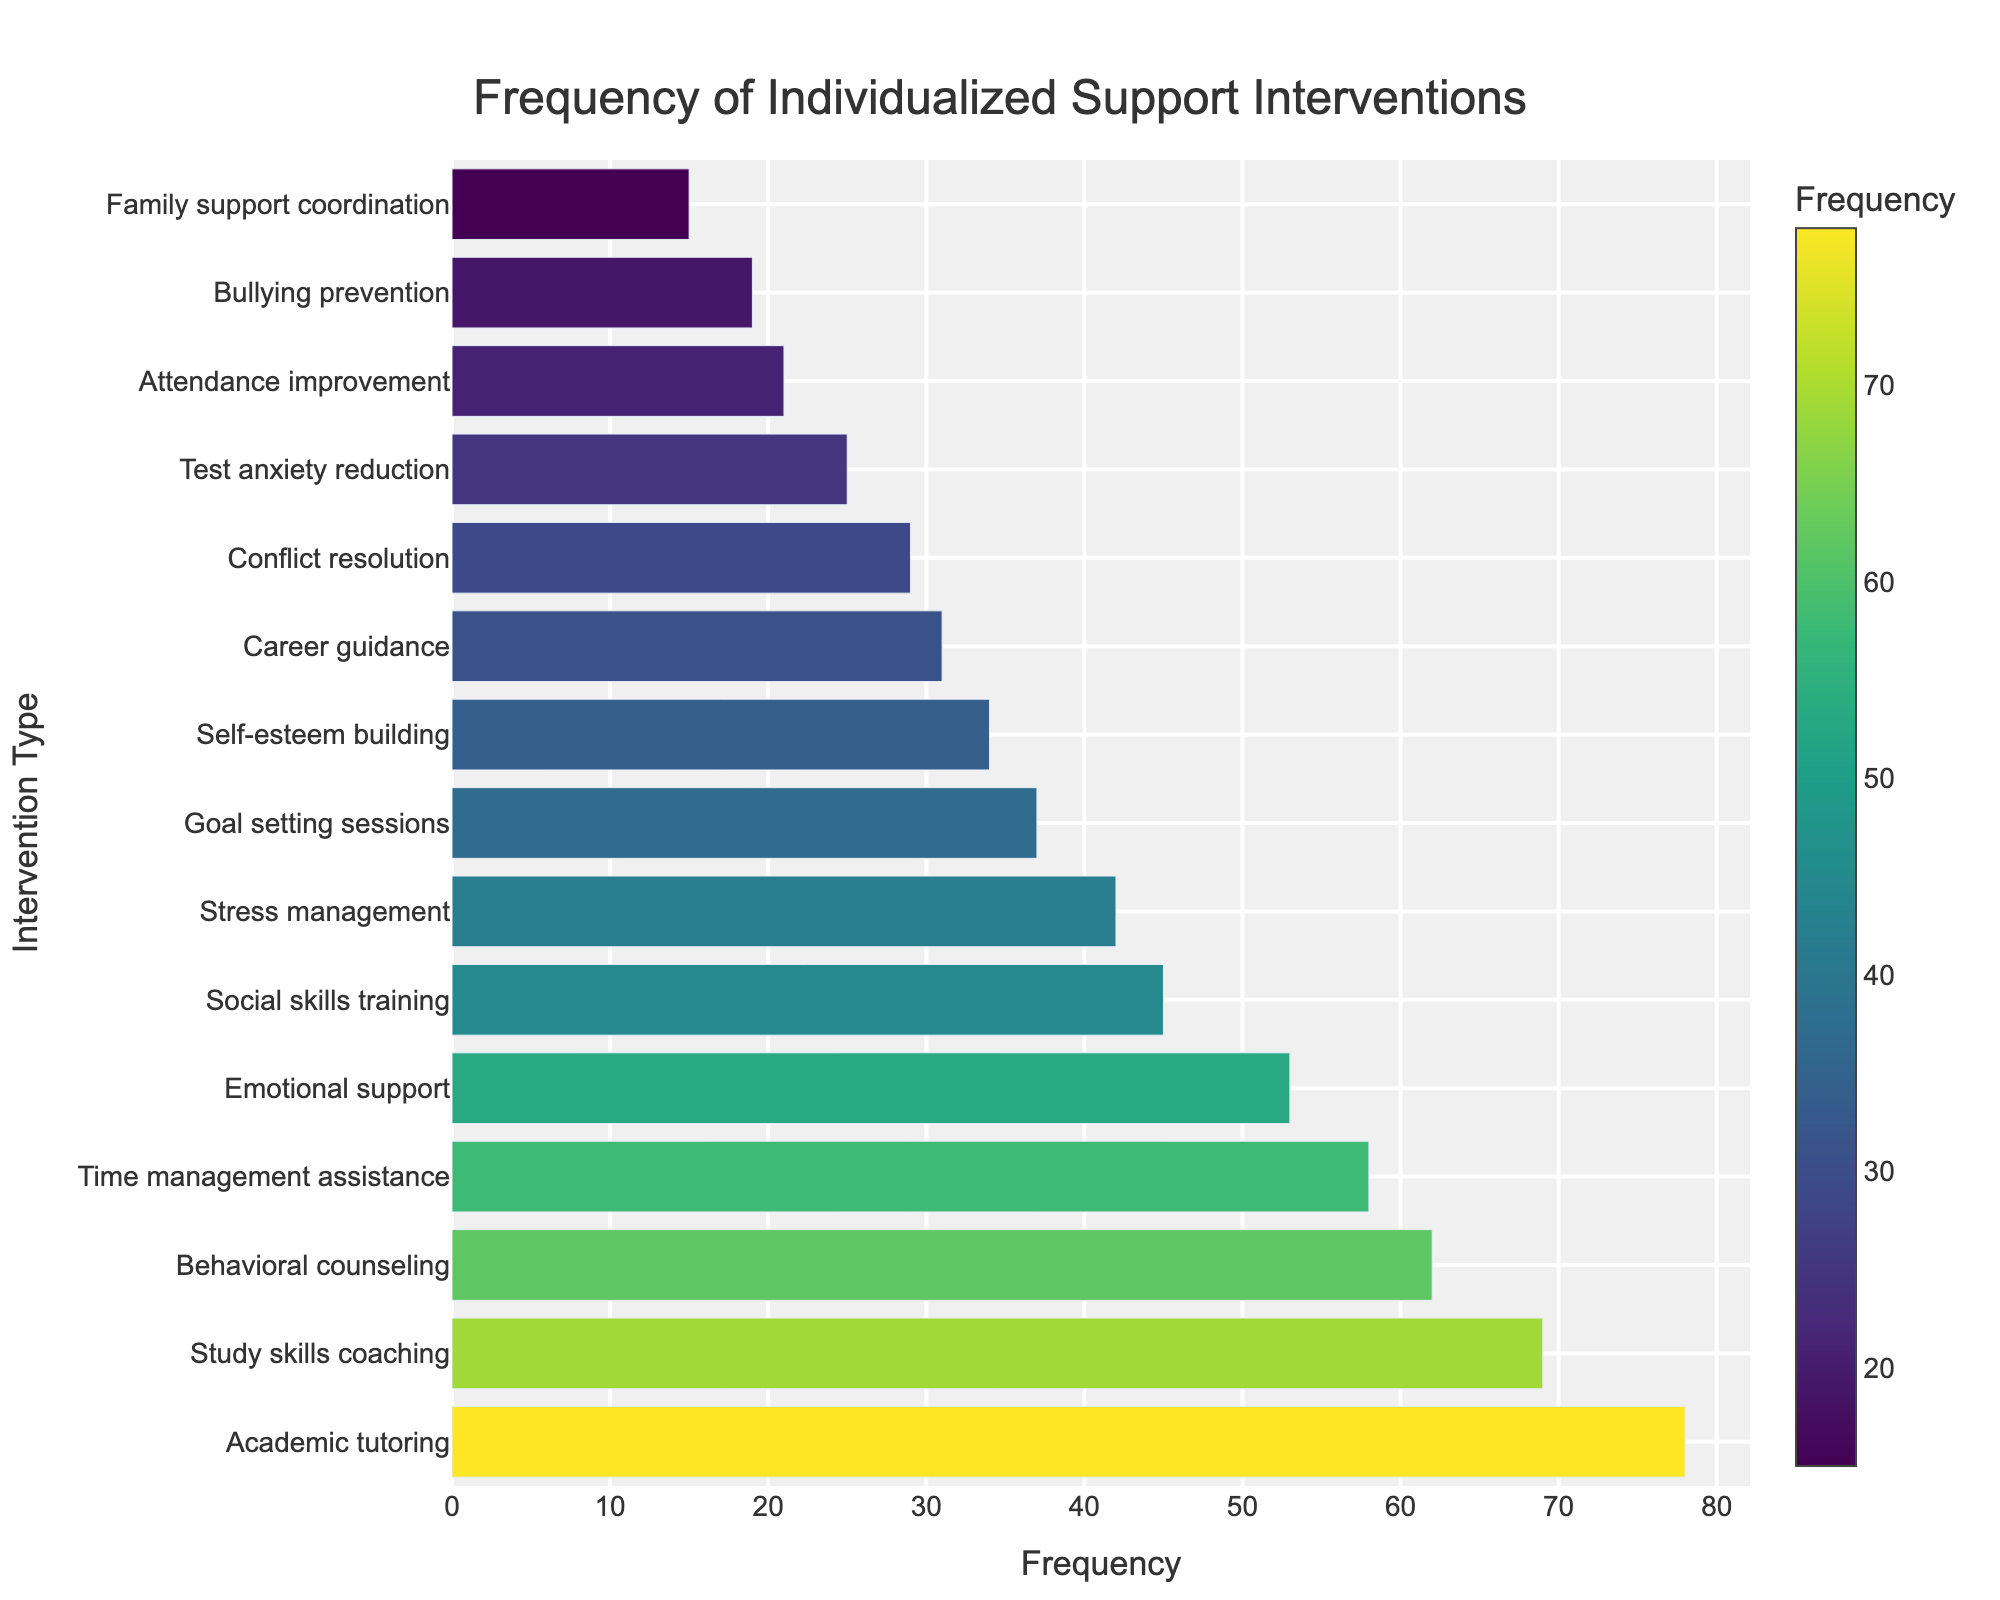Which intervention type has the highest frequency? Look for the bar with the greatest length. Academic tutoring has the highest frequency due to its longest bar in the chart.
Answer: Academic tutoring Which intervention types have a frequency greater than 50? Identify the bars that extend past the 50-mark on the x-axis. Academic tutoring, Behavioral counseling, Emotional support, Study skills coaching, and Time management assistance have frequencies greater than 50.
Answer: Academic tutoring, Behavioral counseling, Emotional support, Study skills coaching, Time management assistance What is the difference in frequency between Academic tutoring and Career guidance? Note the frequencies of Academic tutoring (78) and Career guidance (31), then subtract the smaller value from the larger one: 78 - 31 = 47.
Answer: 47 What is the average frequency of Stress management, Test anxiety reduction, and Conflict resolution? Find the frequencies (Stress management: 42, Test anxiety reduction: 25, Conflict resolution: 29) and add them together (42 + 25 + 29 = 96), then divide by the number of interventions (96 / 3 = 32).
Answer: 32 Which intervention type is depicted in the darkest color? The color bar indicates that darker colors correspond to lower frequencies. Family support coordination is the darkest, implying it has the lowest frequency (15).
Answer: Family support coordination Are there more types of interventions with frequencies above or below 40? Count the bars with frequencies above 40 (7 types) and below 40 (8 types).
Answer: Below 40 How many intervention types have frequencies between 30 and 50? Identify bars whose lengths fall between the 30 and 50 marks: Goal setting sessions (37), Self-esteem building (34), Career guidance (31), Stress management (42), Social skills training (45). There are 5 such interventions.
Answer: 5 Which two intervention types have the closest frequencies? Compare all pairs and find the smallest difference: Self-esteem building (34) and Career guidance (31) have a frequency difference of 3.
Answer: Self-esteem building and Career guidance What is the combined frequency of the three least frequent interventions? Locate the three shortest bars: Bullying prevention (19), Family support coordination (15), Attendance improvement (21). Sum these values: (19 + 15 + 21 = 55).
Answer: 55 Which type of intervention related to skills has the highest frequency? Check the interventions categorized by skills and compare their frequencies: Study skills coaching (69) is the highest.
Answer: Study skills coaching 